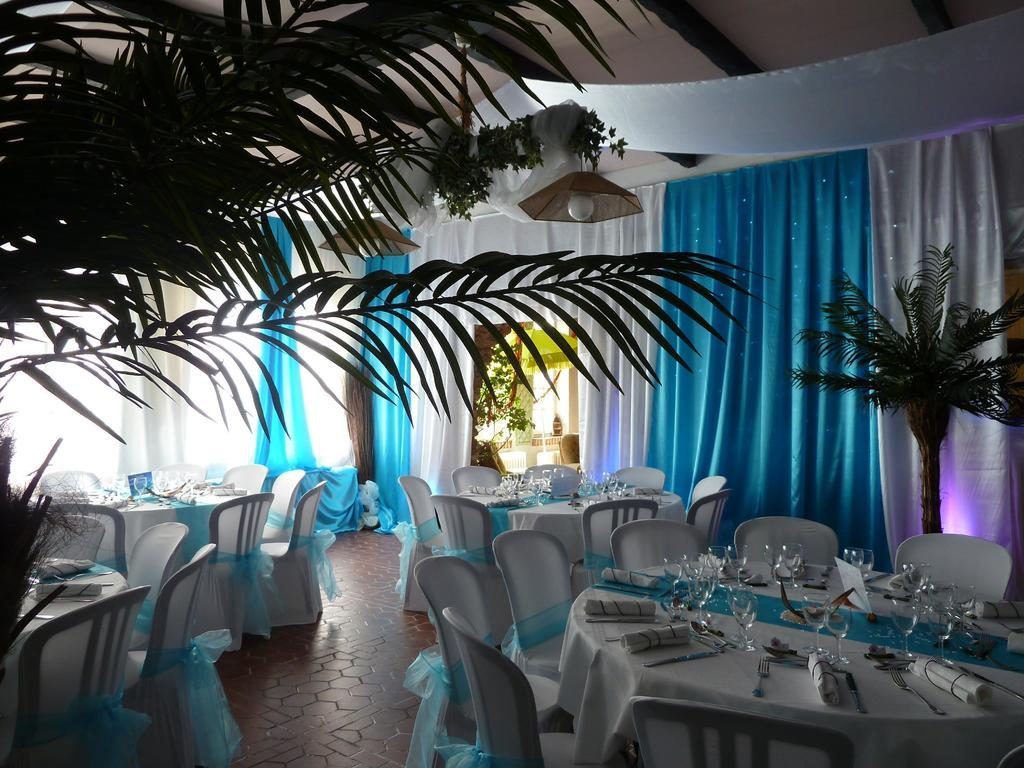What type of living organisms can be seen in the image? Plants are visible in the image. What can be seen in terms of window treatments in the image? There are different colors of curtains in the image. What type of furniture is present in the image? There are tables and chairs in the image. What can be seen providing illumination in the image? There are lights in the image. What objects are placed on the tables in the image? There are glasses on the tables. How many boys are riding bikes in the image? There are no boys or bikes present in the image. What color of ink is being used to write on the curtains in the image? There is no writing or ink visible on the curtains in the image. 